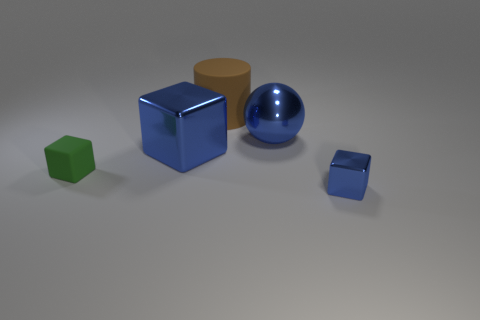Subtract all blue cubes. How many were subtracted if there are1blue cubes left? 1 Add 4 large brown things. How many objects exist? 9 Subtract all cylinders. How many objects are left? 4 Subtract 1 blue spheres. How many objects are left? 4 Subtract all tiny blue things. Subtract all big metal balls. How many objects are left? 3 Add 1 metallic objects. How many metallic objects are left? 4 Add 2 cyan matte balls. How many cyan matte balls exist? 2 